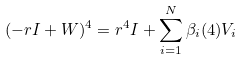Convert formula to latex. <formula><loc_0><loc_0><loc_500><loc_500>( - r { I } + { W } ) ^ { 4 } = r ^ { 4 } { I } + \sum _ { i = 1 } ^ { N } \beta _ { i } ( 4 ) { V } _ { i }</formula> 